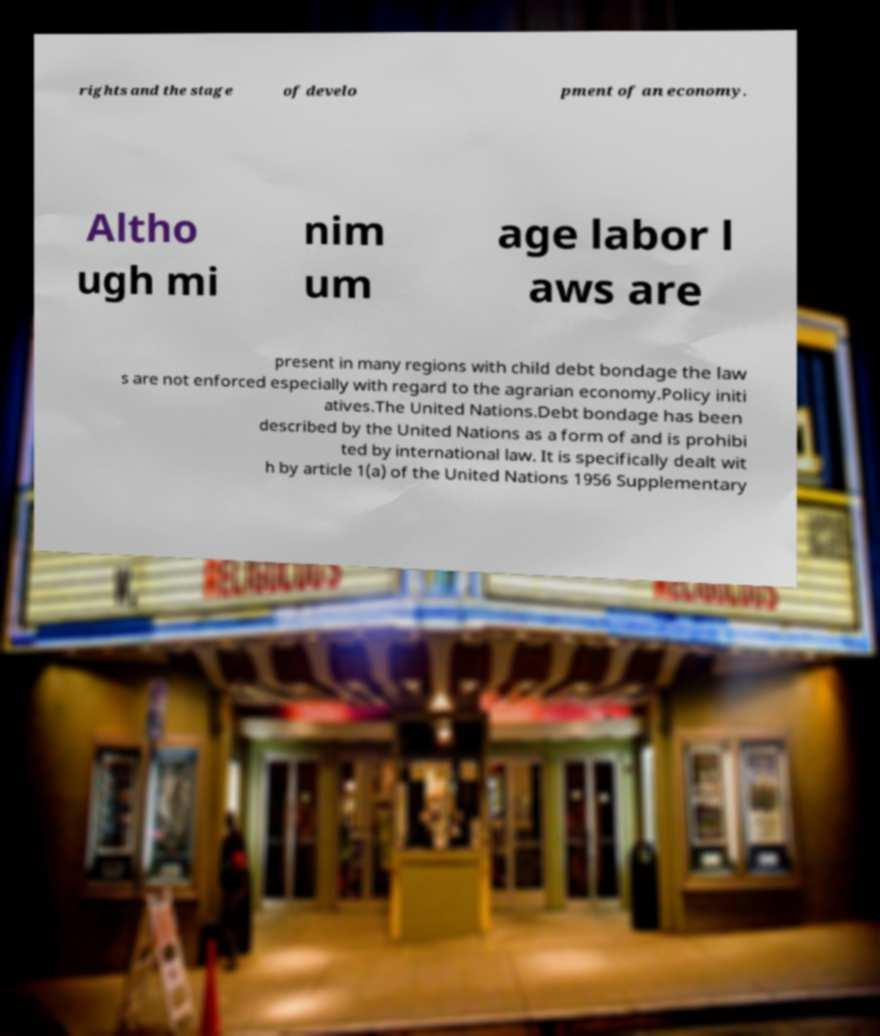Can you accurately transcribe the text from the provided image for me? rights and the stage of develo pment of an economy. Altho ugh mi nim um age labor l aws are present in many regions with child debt bondage the law s are not enforced especially with regard to the agrarian economy.Policy initi atives.The United Nations.Debt bondage has been described by the United Nations as a form of and is prohibi ted by international law. It is specifically dealt wit h by article 1(a) of the United Nations 1956 Supplementary 